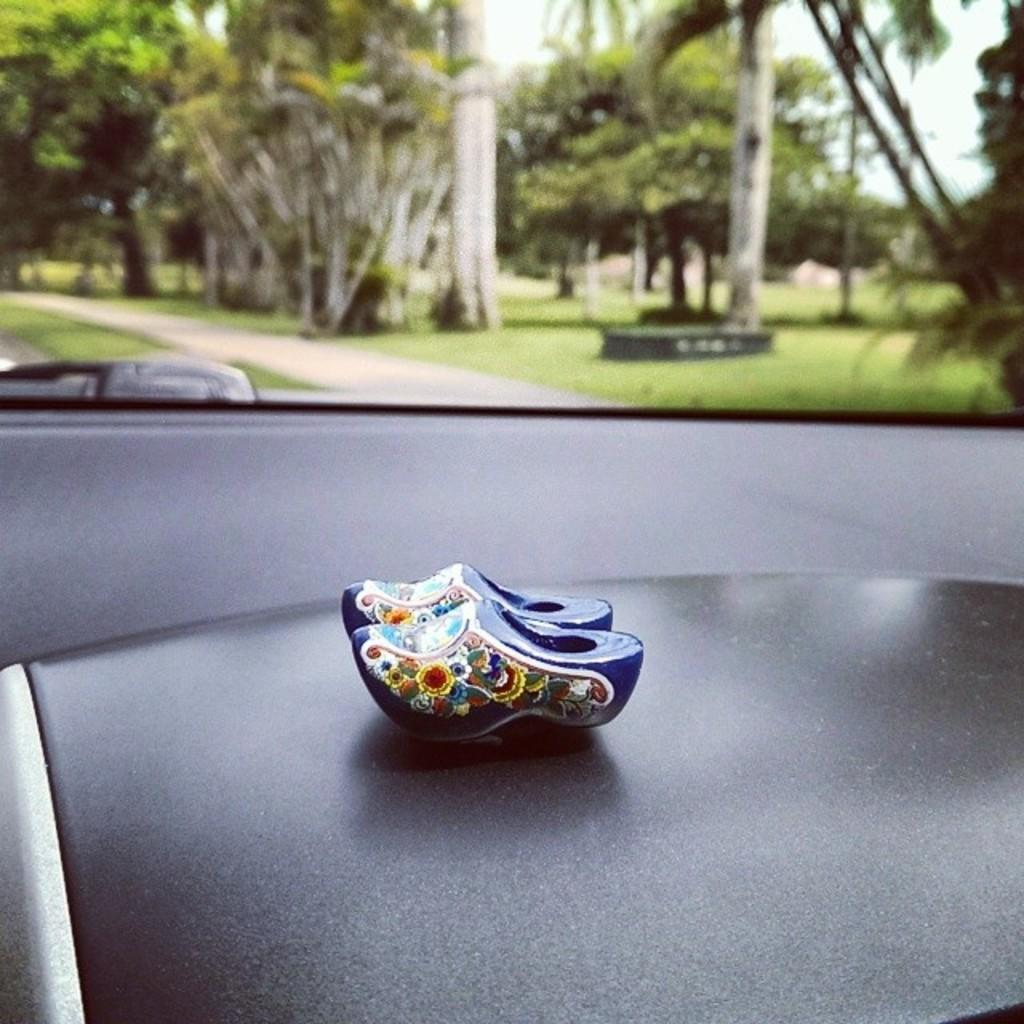What is the main subject of the image? The main subject of the image is a vehicle with objects inside. What can be seen in the background of the image? There are trees, the sky, and other objects visible in the background of the image. How many heads of cabbage can be seen in the image? There is no cabbage present in the image. How many children are playing near the vehicle in the image? There is no mention of children in the image; it only shows a vehicle with objects inside and the background. 